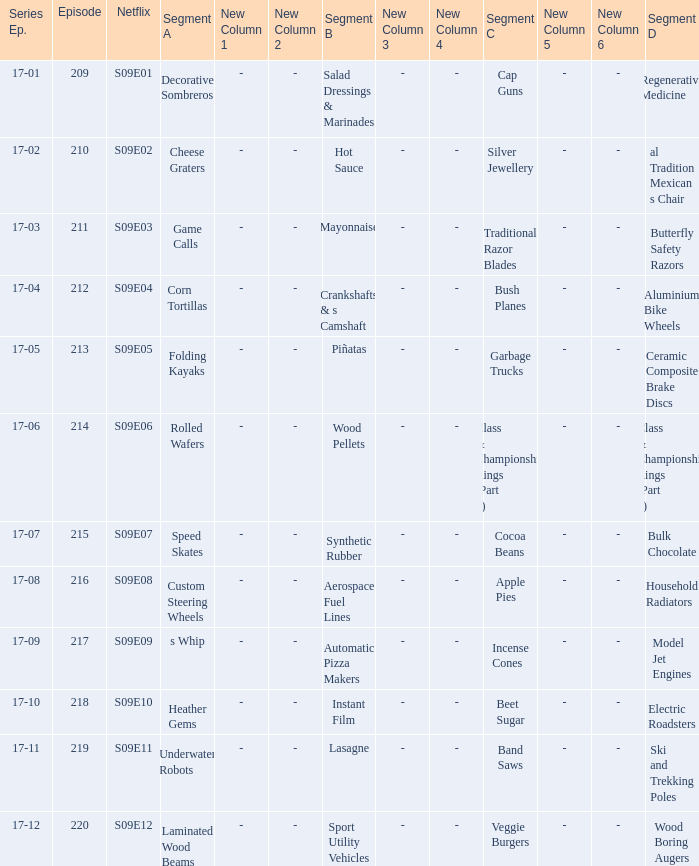How many segments involve wood boring augers Laminated Wood Beams. 